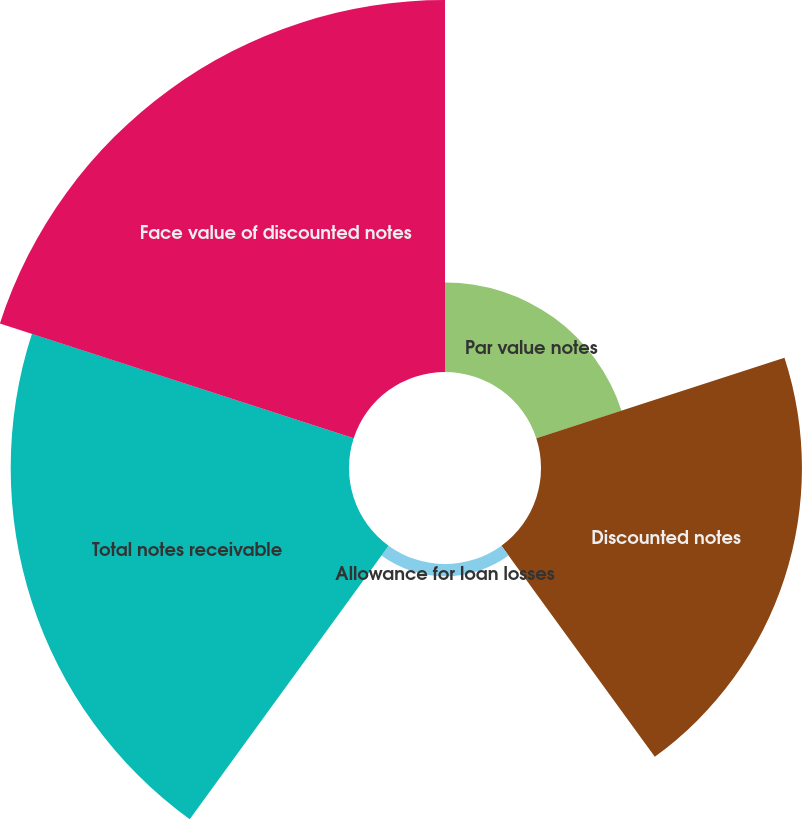Convert chart to OTSL. <chart><loc_0><loc_0><loc_500><loc_500><pie_chart><fcel>Par value notes<fcel>Discounted notes<fcel>Allowance for loan losses<fcel>Total notes receivable<fcel>Face value of discounted notes<nl><fcel>8.35%<fcel>24.32%<fcel>1.14%<fcel>31.53%<fcel>34.67%<nl></chart> 